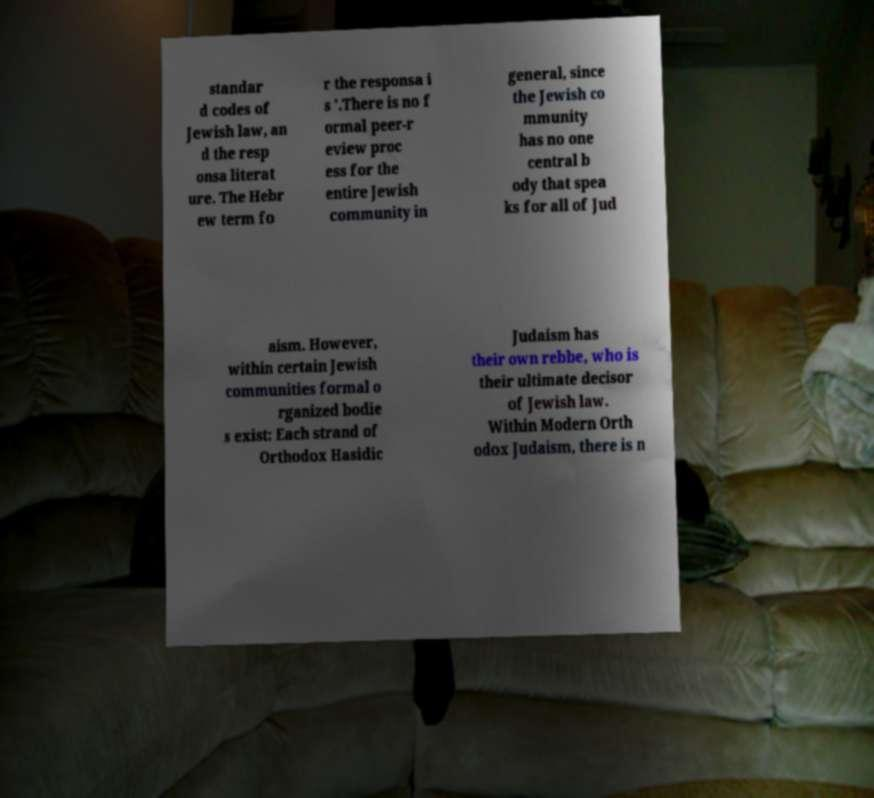What messages or text are displayed in this image? I need them in a readable, typed format. standar d codes of Jewish law, an d the resp onsa literat ure. The Hebr ew term fo r the responsa i s '.There is no f ormal peer-r eview proc ess for the entire Jewish community in general, since the Jewish co mmunity has no one central b ody that spea ks for all of Jud aism. However, within certain Jewish communities formal o rganized bodie s exist: Each strand of Orthodox Hasidic Judaism has their own rebbe, who is their ultimate decisor of Jewish law. Within Modern Orth odox Judaism, there is n 